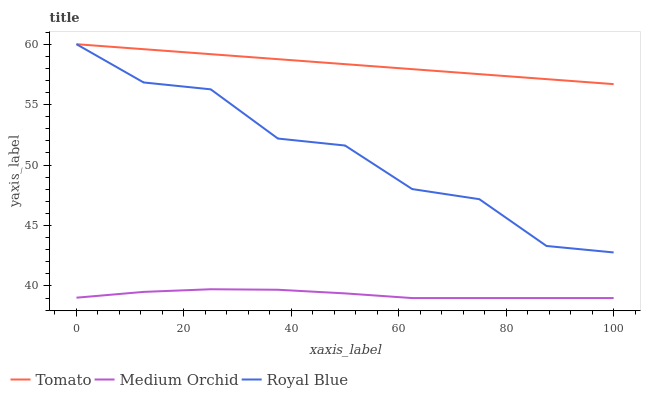Does Medium Orchid have the minimum area under the curve?
Answer yes or no. Yes. Does Tomato have the maximum area under the curve?
Answer yes or no. Yes. Does Royal Blue have the minimum area under the curve?
Answer yes or no. No. Does Royal Blue have the maximum area under the curve?
Answer yes or no. No. Is Tomato the smoothest?
Answer yes or no. Yes. Is Royal Blue the roughest?
Answer yes or no. Yes. Is Medium Orchid the smoothest?
Answer yes or no. No. Is Medium Orchid the roughest?
Answer yes or no. No. Does Royal Blue have the lowest value?
Answer yes or no. No. Does Medium Orchid have the highest value?
Answer yes or no. No. Is Medium Orchid less than Royal Blue?
Answer yes or no. Yes. Is Tomato greater than Medium Orchid?
Answer yes or no. Yes. Does Medium Orchid intersect Royal Blue?
Answer yes or no. No. 